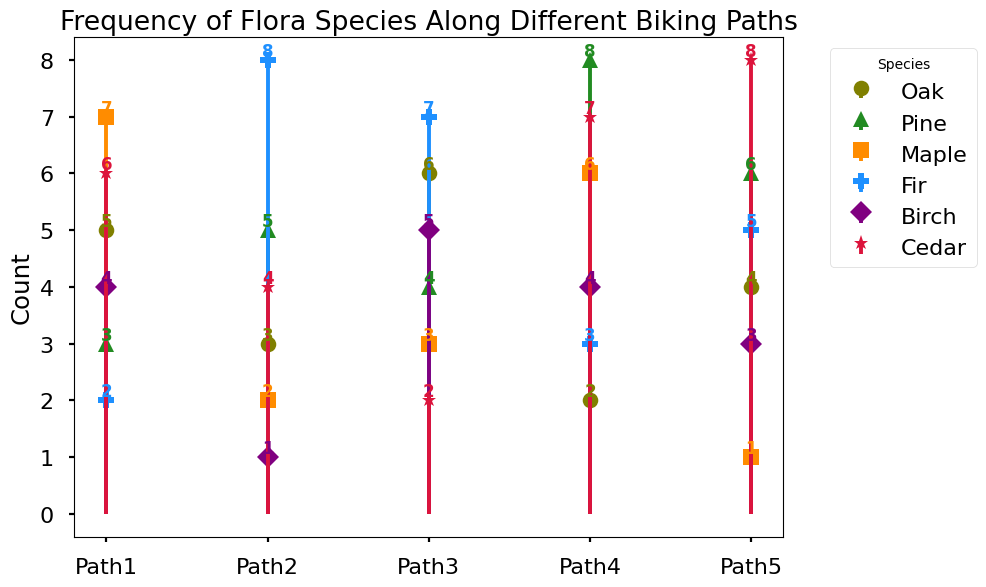Which species has the highest count on Path 1? Observing the stem plot, the highest count on Path 1 corresponds to Maple, with a count of 7.
Answer: Maple Which species has the lowest count on Path 2? Looking at the stem plot for Path 2, Birch has the lowest count, with a value of 1.
Answer: Birch How many species have a count greater than 5 on Path 3? On Path 3, Oak (6) and Fir (7) have counts greater than 5, summing up to two species.
Answer: 2 What is the difference between the highest and lowest count on Path 4? The highest count on Path 4 is for Pine (8), and the lowest is for Oak (2). The difference is 8 - 2 = 6.
Answer: 6 Which path has the highest total count of all species combined? Summing the counts for all species on each path:
Path 1: 5 + 3 + 7 + 2 + 4 + 6 = 27
Path 2: 3 + 5 + 2 + 8 + 1 + 4 = 23
Path 3: 6 + 4 + 3 + 7 + 5 + 2 = 27
Path 4: 2 + 8 + 6 + 3 + 4 + 7 = 30
Path 5: 4 + 6 + 1 + 5 + 3 + 8 = 27
Path 4 has the highest total count of 30.
Answer: Path 4 On which path is Cedar most abundant? On examining the stem plot, Cedar has the highest count on Path 5 with a value of 8.
Answer: Path 5 By how much does the count of Pine in Path 4 exceed the count of Pine in Path 1? Pine has a count of 8 in Path 4 and 3 in Path 1. The difference is 8 - 3 = 5.
Answer: 5 Which two species have equal counts on Path 1? Inspecting Path 1, both Birch and Pine have equal counts of 4.
Answer: Birch and Pine 